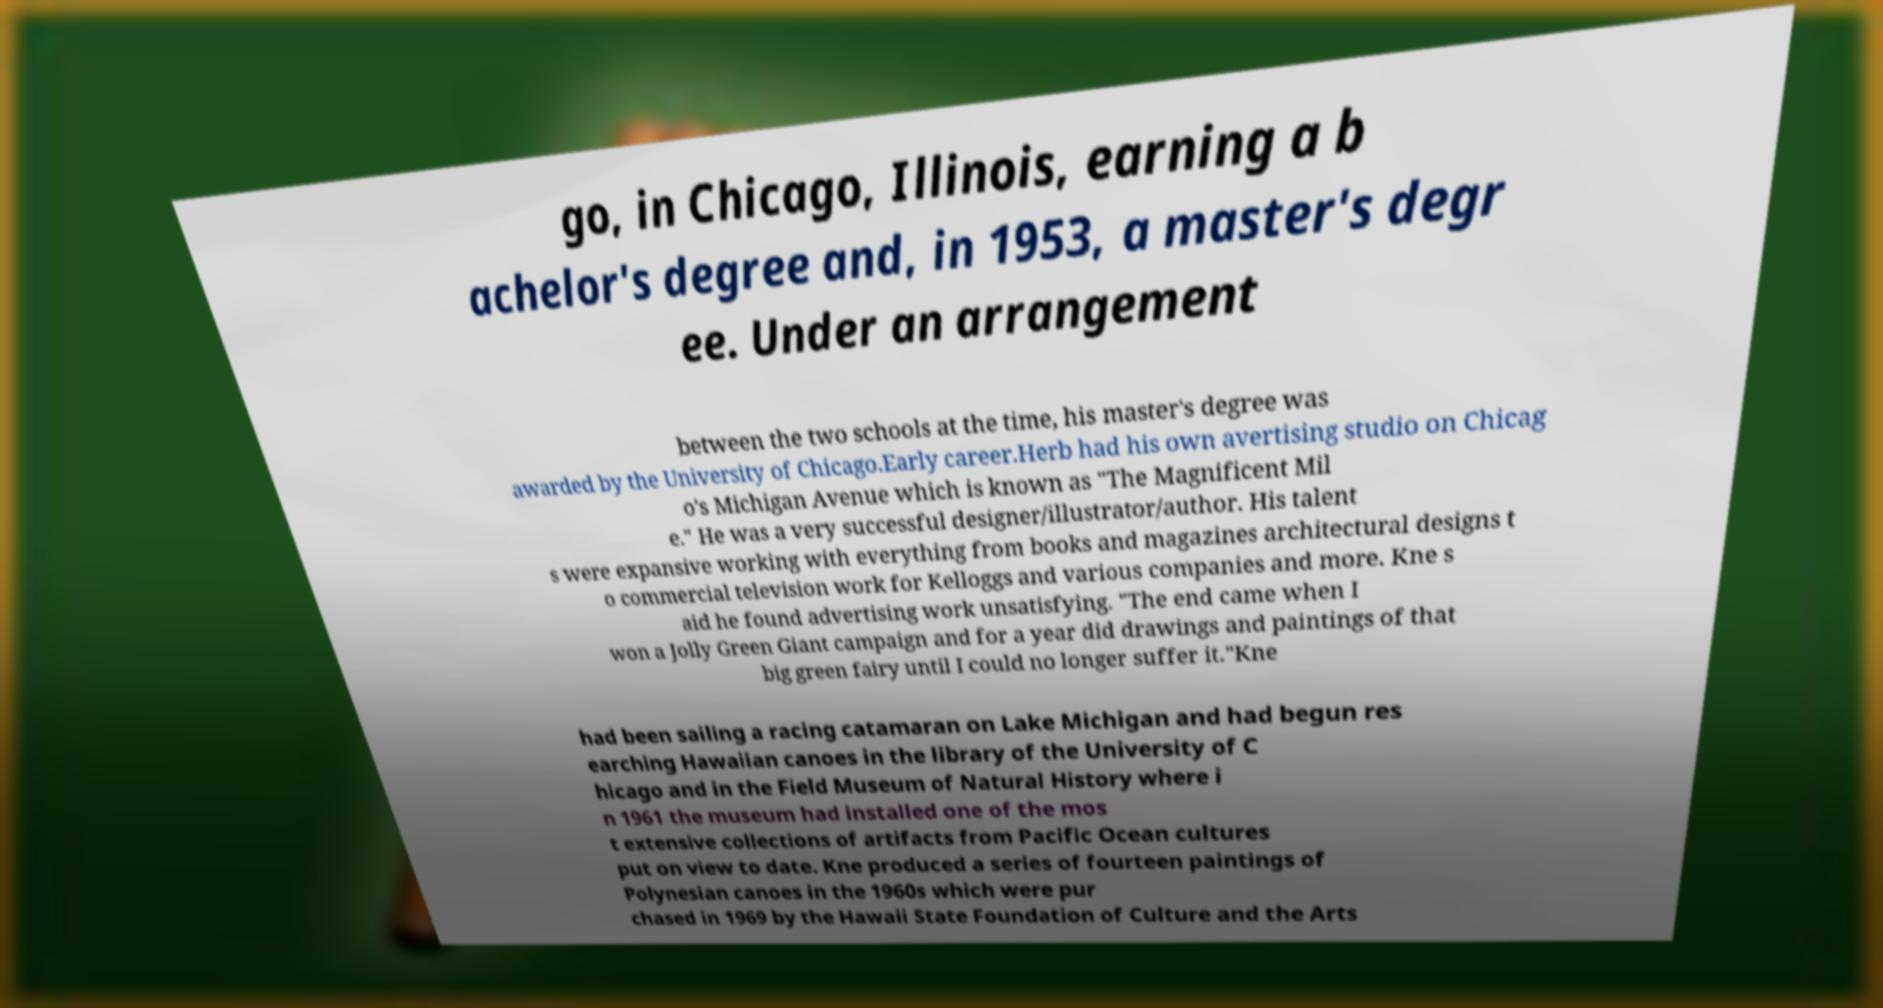Can you accurately transcribe the text from the provided image for me? go, in Chicago, Illinois, earning a b achelor's degree and, in 1953, a master's degr ee. Under an arrangement between the two schools at the time, his master's degree was awarded by the University of Chicago.Early career.Herb had his own avertising studio on Chicag o's Michigan Avenue which is known as "The Magnificent Mil e." He was a very successful designer/illustrator/author. His talent s were expansive working with everything from books and magazines architectural designs t o commercial television work for Kelloggs and various companies and more. Kne s aid he found advertising work unsatisfying. "The end came when I won a Jolly Green Giant campaign and for a year did drawings and paintings of that big green fairy until I could no longer suffer it."Kne had been sailing a racing catamaran on Lake Michigan and had begun res earching Hawaiian canoes in the library of the University of C hicago and in the Field Museum of Natural History where i n 1961 the museum had installed one of the mos t extensive collections of artifacts from Pacific Ocean cultures put on view to date. Kne produced a series of fourteen paintings of Polynesian canoes in the 1960s which were pur chased in 1969 by the Hawaii State Foundation of Culture and the Arts 